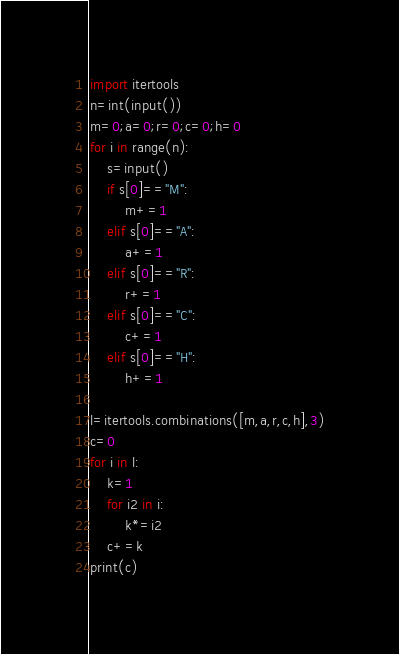<code> <loc_0><loc_0><loc_500><loc_500><_Python_>import itertools
n=int(input())
m=0;a=0;r=0;c=0;h=0
for i in range(n):
    s=input()
    if s[0]=="M":
        m+=1
    elif s[0]=="A":
        a+=1
    elif s[0]=="R":
        r+=1
    elif s[0]=="C":
        c+=1
    elif s[0]=="H":
        h+=1

l=itertools.combinations([m,a,r,c,h],3)
c=0
for i in l:
    k=1
    for i2 in i:
        k*=i2
    c+=k
print(c)
</code> 